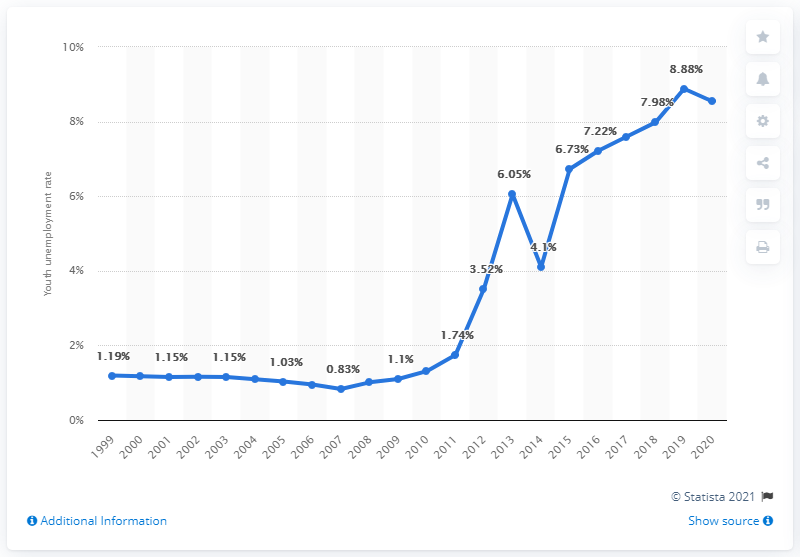Mention a couple of crucial points in this snapshot. In 2020, Pakistan's youth unemployment rate was estimated to be 8.54%. 